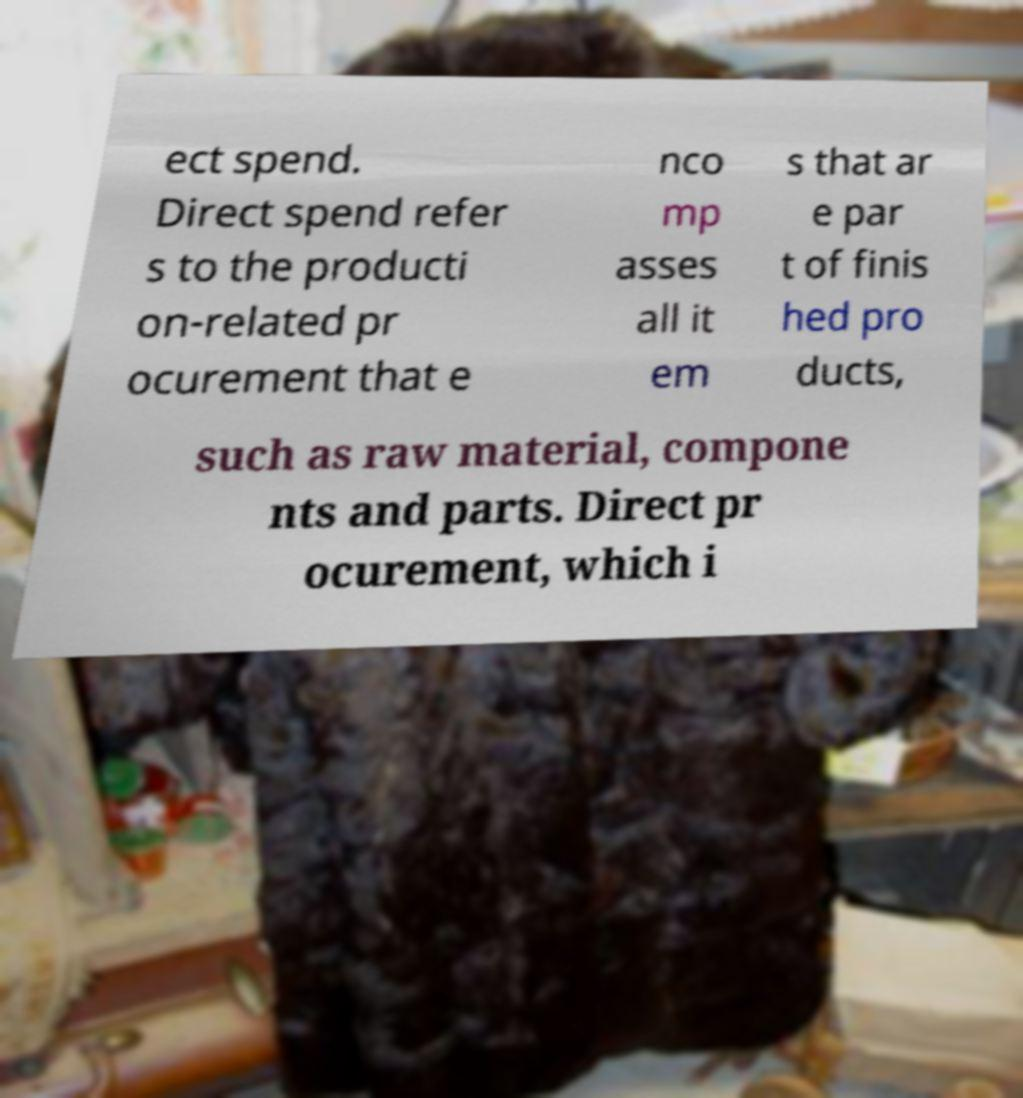Could you assist in decoding the text presented in this image and type it out clearly? ect spend. Direct spend refer s to the producti on-related pr ocurement that e nco mp asses all it em s that ar e par t of finis hed pro ducts, such as raw material, compone nts and parts. Direct pr ocurement, which i 